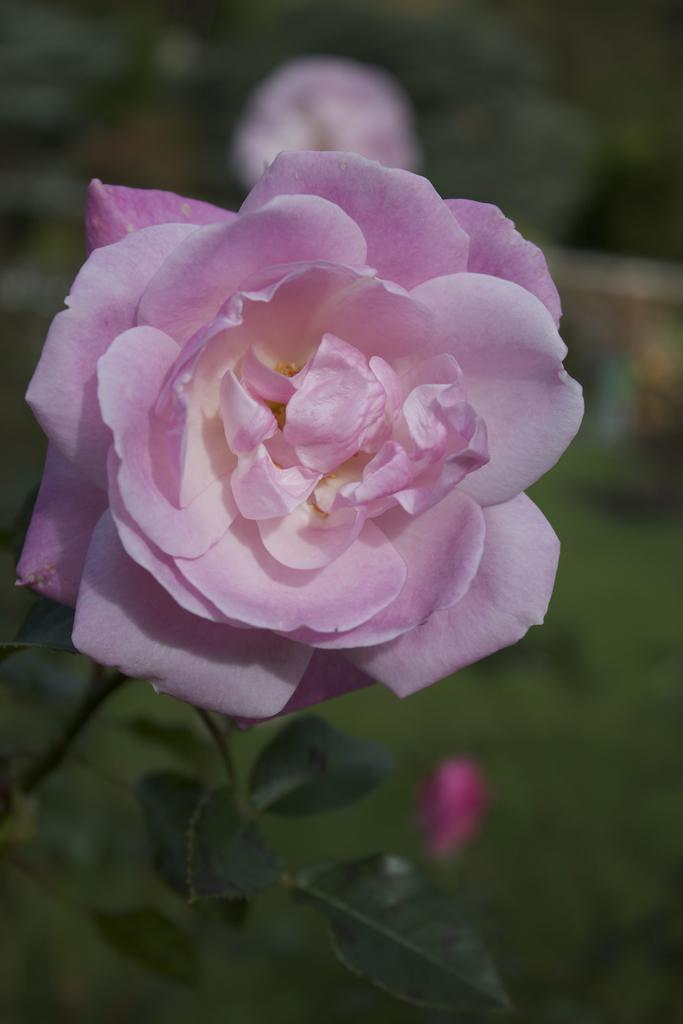What type of flower is in the image? There is a rose in the image. How would you describe the background of the image? The background of the image is blurred. What else can be seen at the bottom of the image? There are leaves at the bottom of the image. What channel is the rose featured on in the image? There is no channel present in the image; it is a photograph or illustration of a rose. 